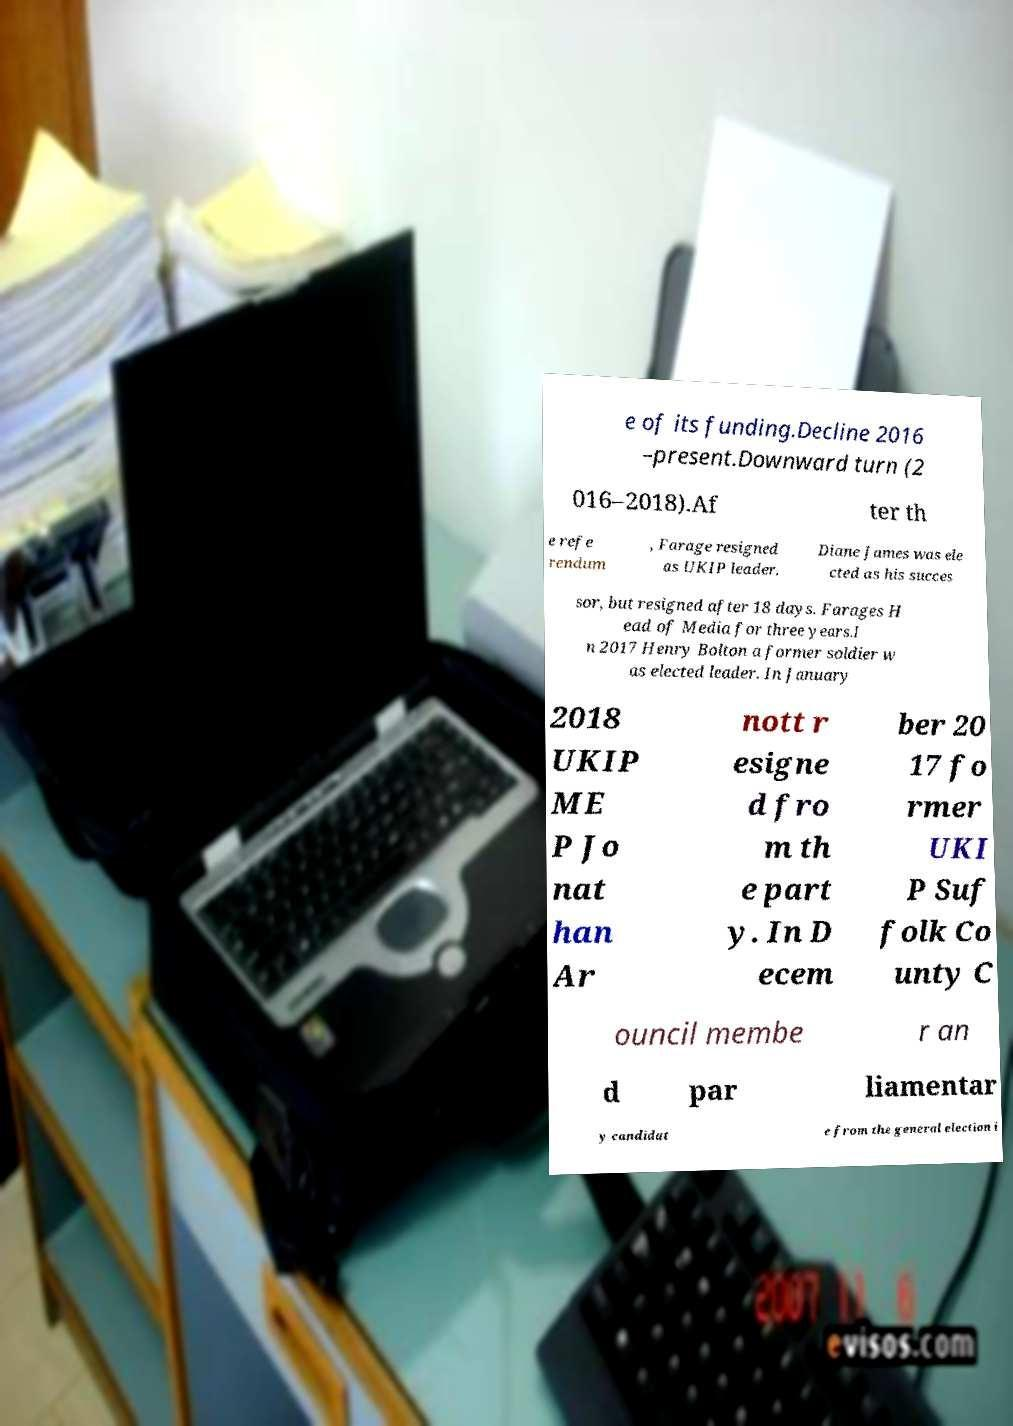For documentation purposes, I need the text within this image transcribed. Could you provide that? e of its funding.Decline 2016 –present.Downward turn (2 016–2018).Af ter th e refe rendum , Farage resigned as UKIP leader. Diane James was ele cted as his succes sor, but resigned after 18 days. Farages H ead of Media for three years.I n 2017 Henry Bolton a former soldier w as elected leader. In January 2018 UKIP ME P Jo nat han Ar nott r esigne d fro m th e part y. In D ecem ber 20 17 fo rmer UKI P Suf folk Co unty C ouncil membe r an d par liamentar y candidat e from the general election i 